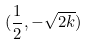Convert formula to latex. <formula><loc_0><loc_0><loc_500><loc_500>( \frac { 1 } { 2 } , - \sqrt { 2 k } )</formula> 